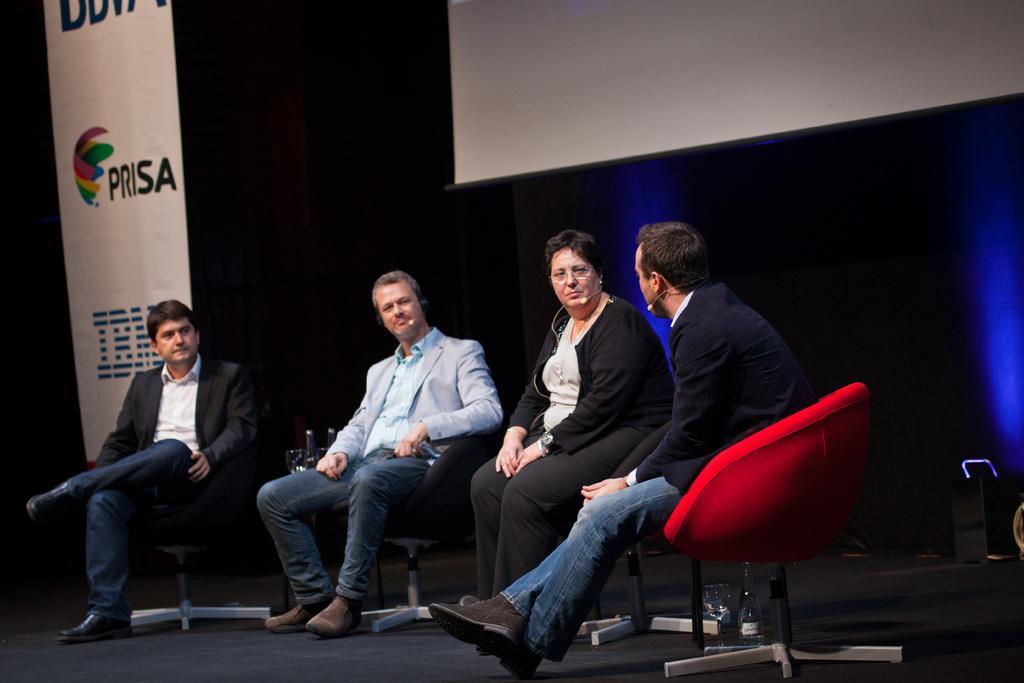Please provide a concise description of this image. In this image we can see three men and one woman sitting on the chairs. In the background we can see a banner and also the screen and the curtain. At the bottom there is stage and also a glass and a bottle. 